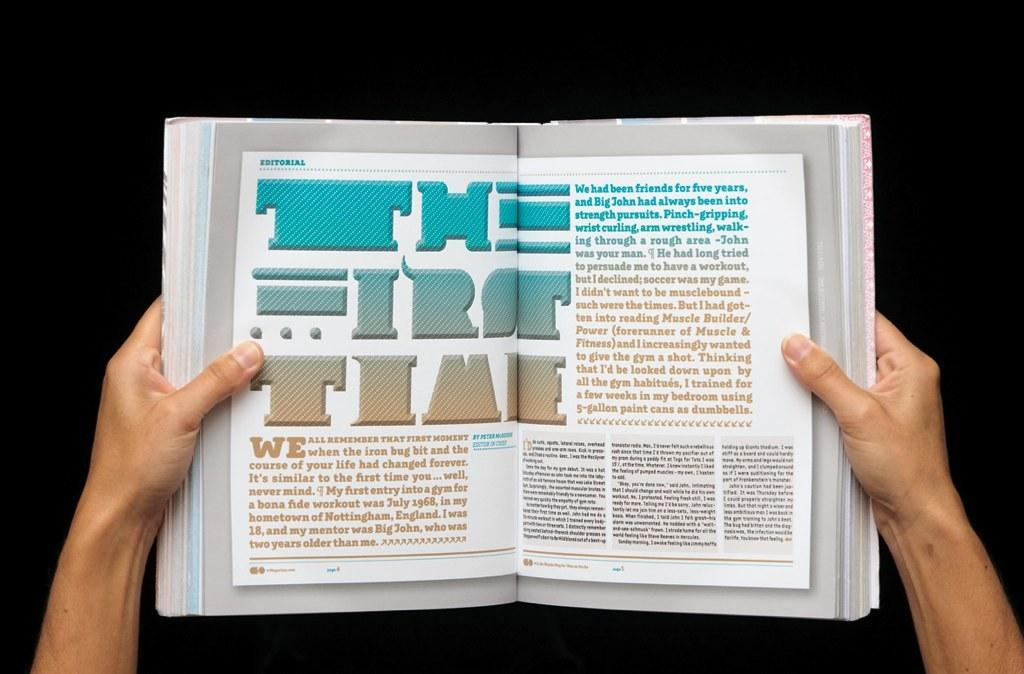<image>
Summarize the visual content of the image. A magazine open to an editorial article titled "The First Time" 